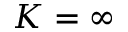Convert formula to latex. <formula><loc_0><loc_0><loc_500><loc_500>K = \infty</formula> 